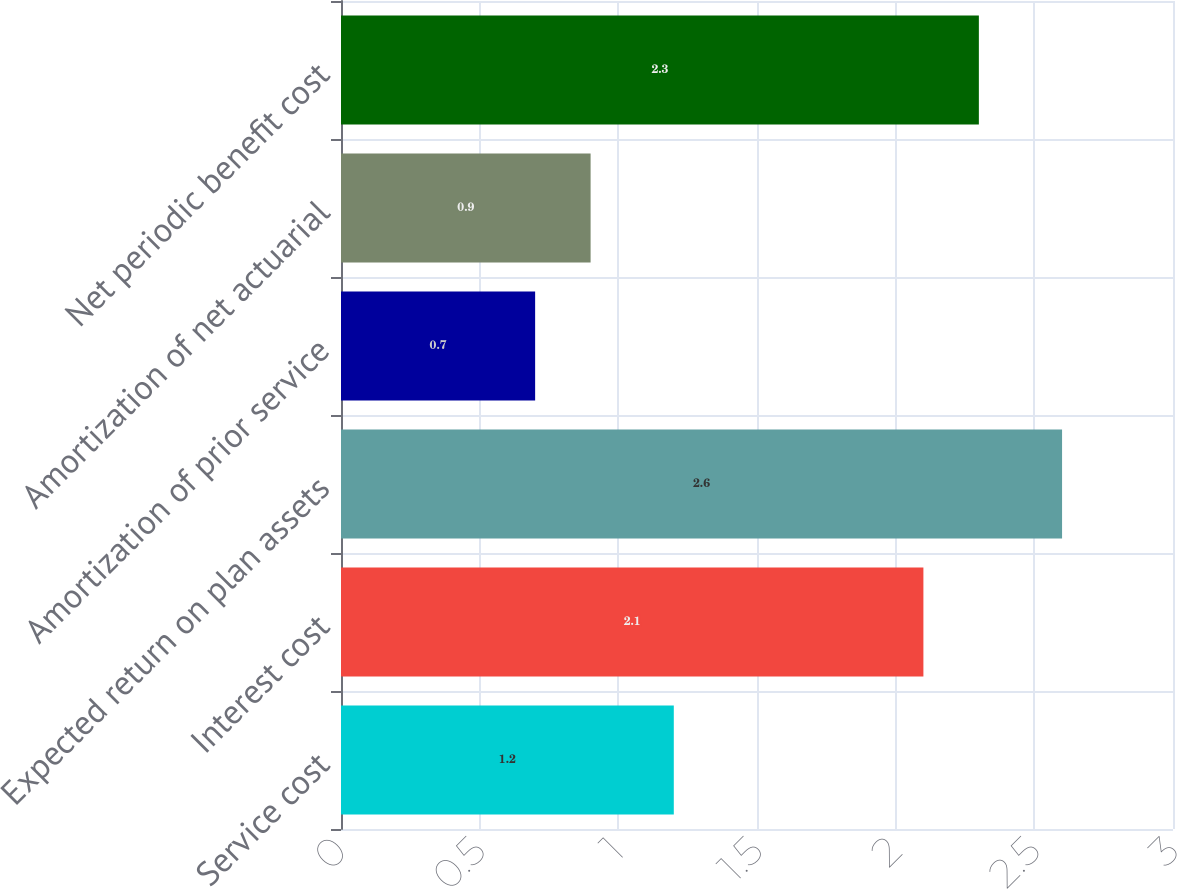Convert chart to OTSL. <chart><loc_0><loc_0><loc_500><loc_500><bar_chart><fcel>Service cost<fcel>Interest cost<fcel>Expected return on plan assets<fcel>Amortization of prior service<fcel>Amortization of net actuarial<fcel>Net periodic benefit cost<nl><fcel>1.2<fcel>2.1<fcel>2.6<fcel>0.7<fcel>0.9<fcel>2.3<nl></chart> 